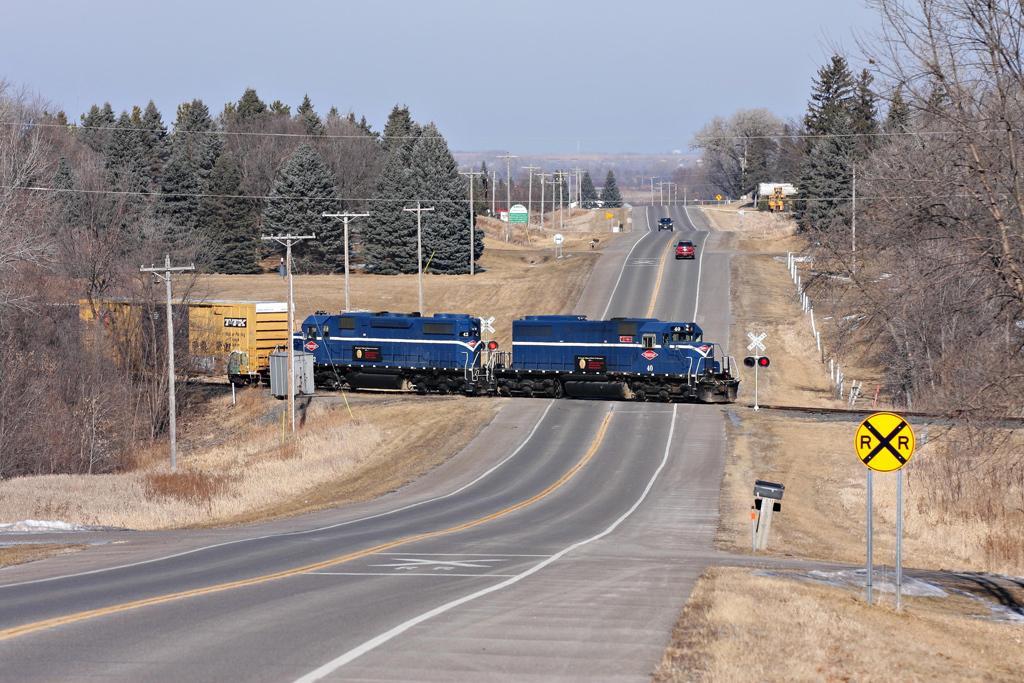Can you describe this image briefly? In this image there is a road in the middle. On the right side there is a sign board. In the middle we can see that there is a train which is crossing the road. In the background there are two cars on the road. On the left side there are trees. Beside the trees there are electric poles to which there are wires. At the top there is the sky. 